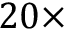<formula> <loc_0><loc_0><loc_500><loc_500>2 0 \times</formula> 